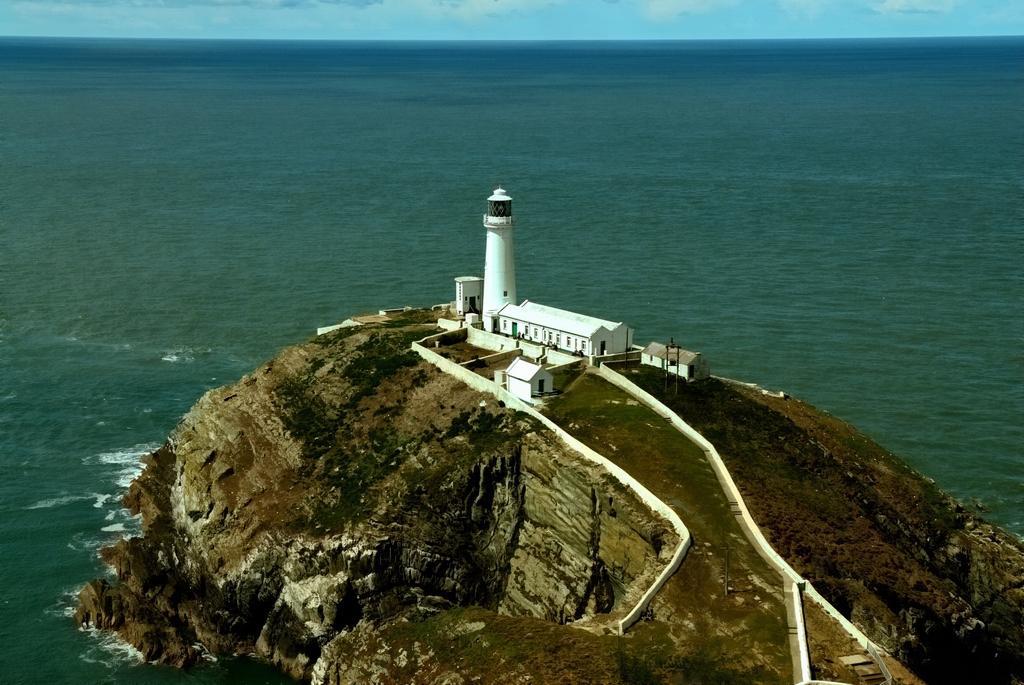Can you describe this image briefly? In this image in front there is an island. There is a lighthouse. There are buildings. In the background of the image there is sky. 